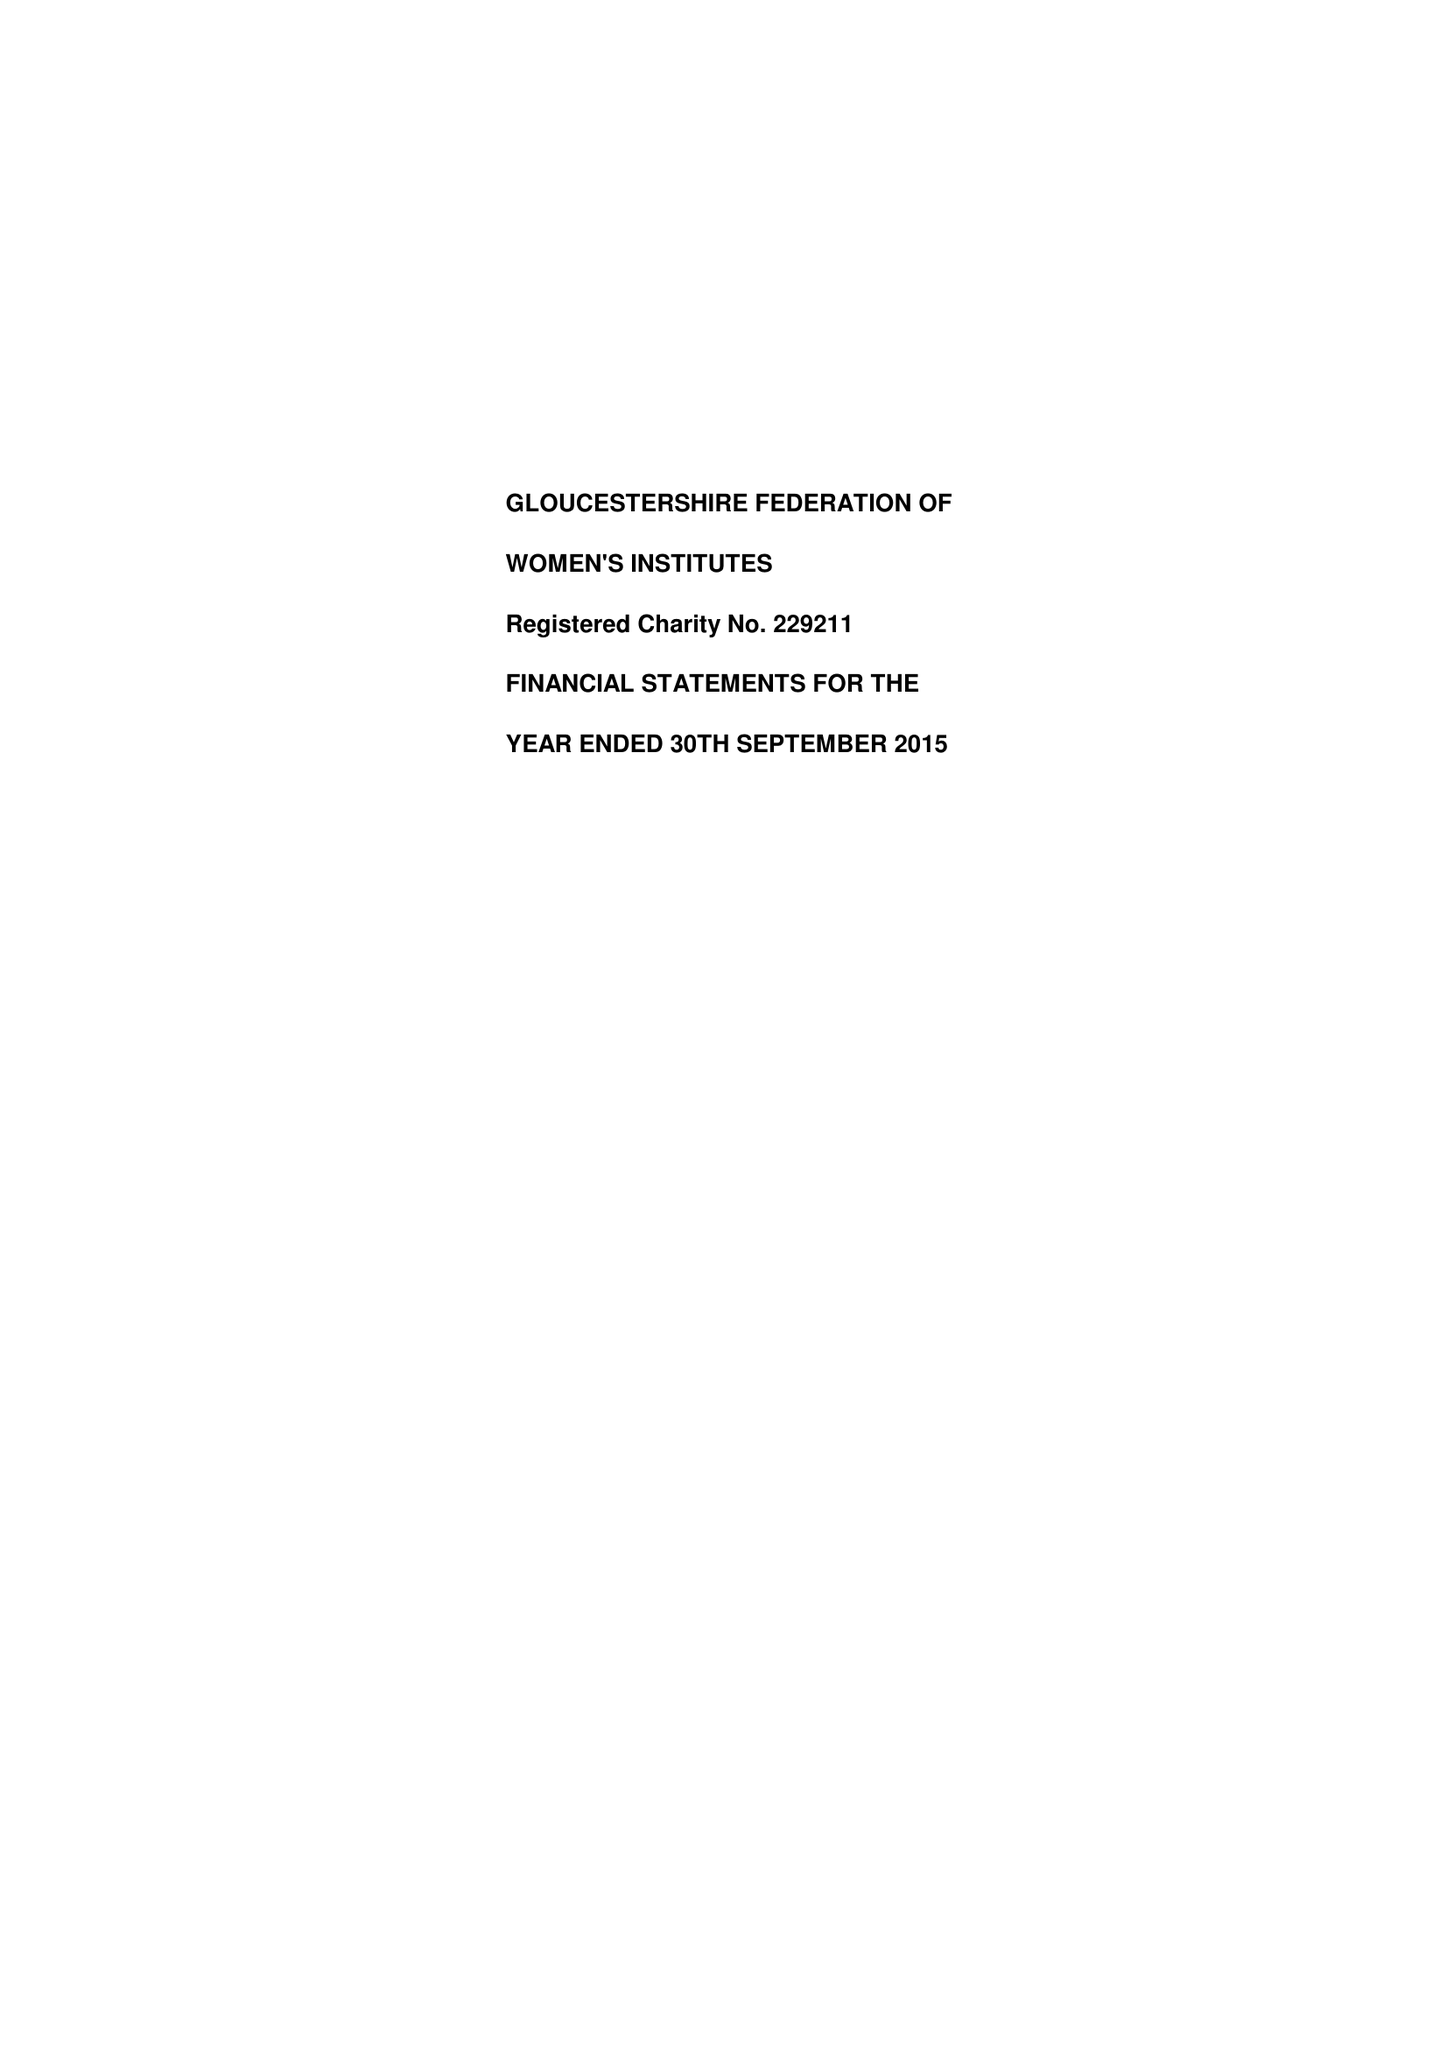What is the value for the spending_annually_in_british_pounds?
Answer the question using a single word or phrase. 232790.00 